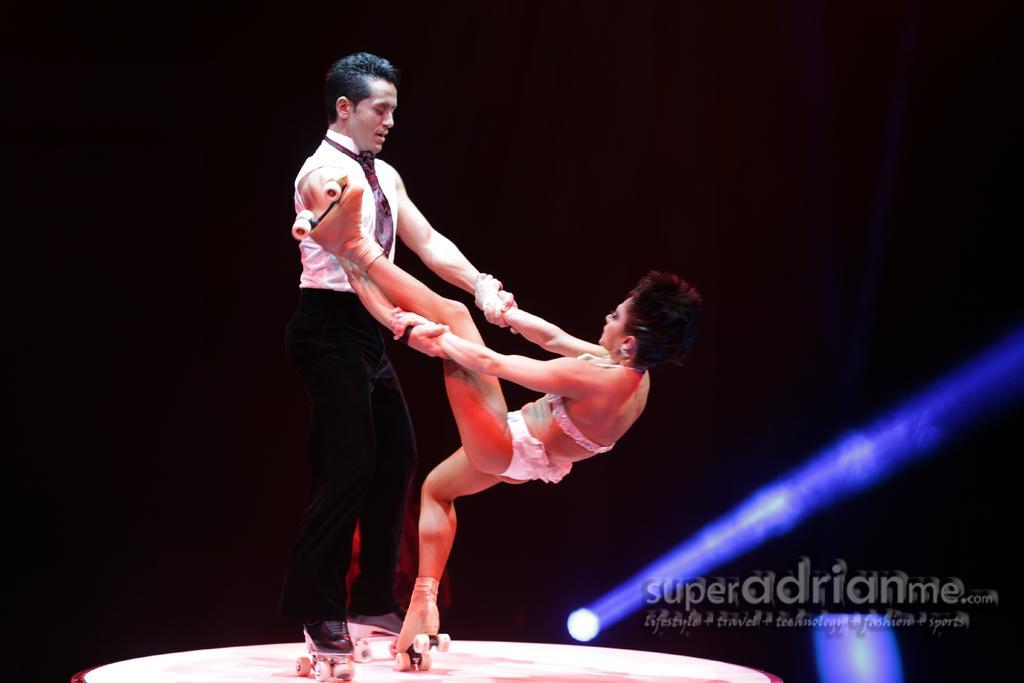Could you give a brief overview of what you see in this image? In this image we can see a man and a woman wearing the skateboards and are present on the surface. The background is in black color. We can also see the focus light and at the bottom there is text. 